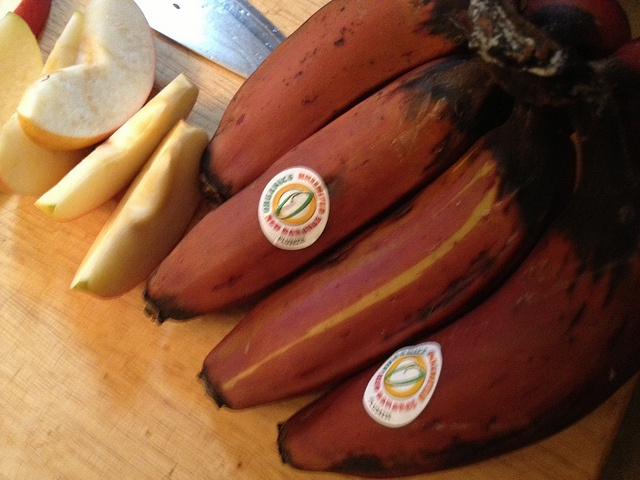Describe the objects in this image and their specific colors. I can see banana in beige, black, maroon, tan, and lightgray tones, dining table in beige, tan, maroon, and red tones, banana in beige, maroon, black, and brown tones, banana in beige, maroon, brown, and black tones, and banana in beige, maroon, and brown tones in this image. 